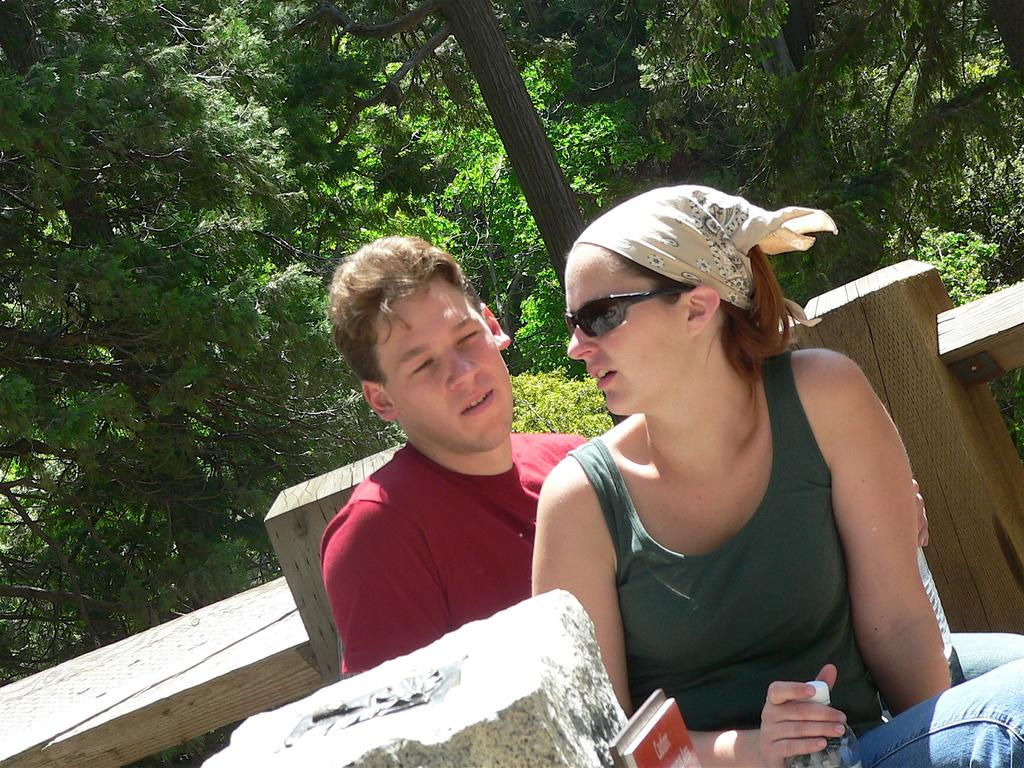What is the woman doing in the image? The woman is sitting in the image. What is the woman holding in the image? The woman is holding a bottle. What is the man doing in the image? The man is sitting in the image. What is the man holding in the image? The man is holding a bottle. What can be seen in the background of the image? There is a wooden railing and trees in the background of the image. What type of crow can be seen playing on the school playground in the image? There is no crow, school, or playground present in the image. 